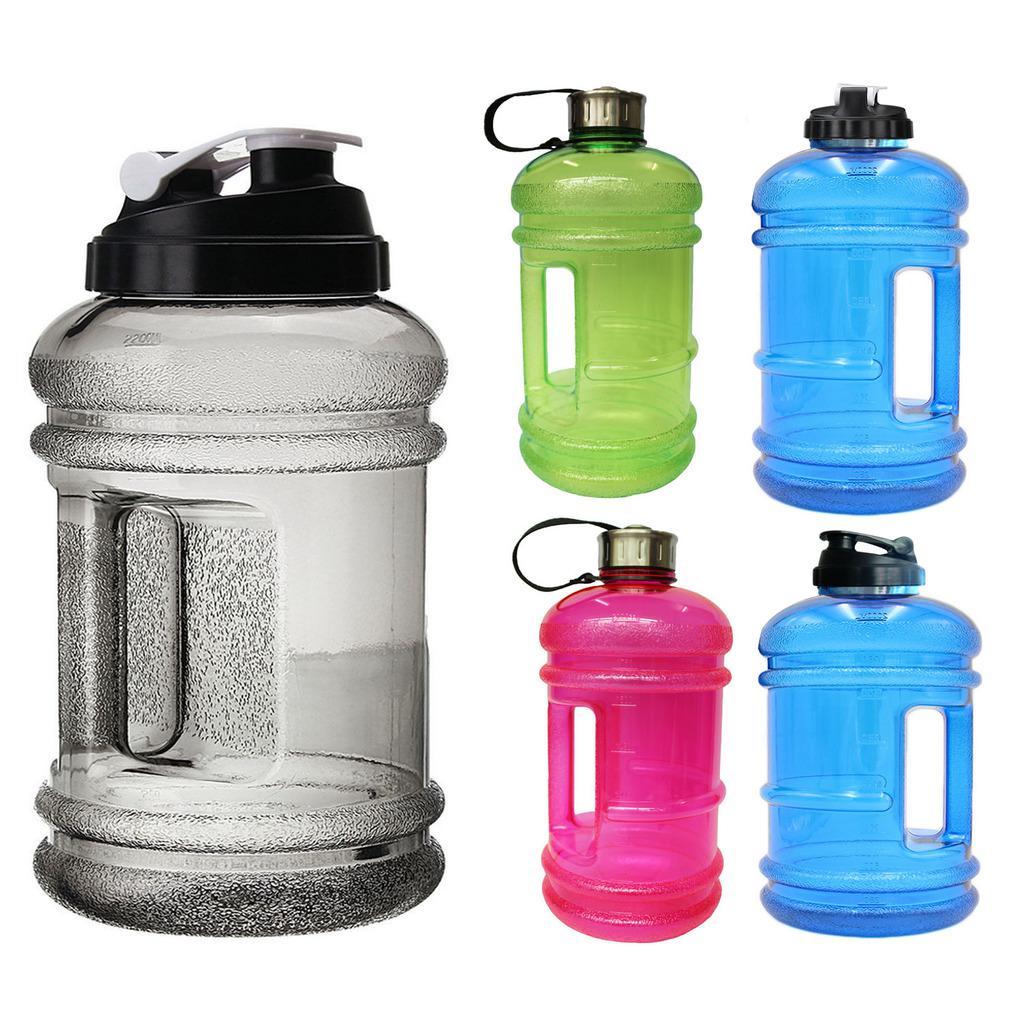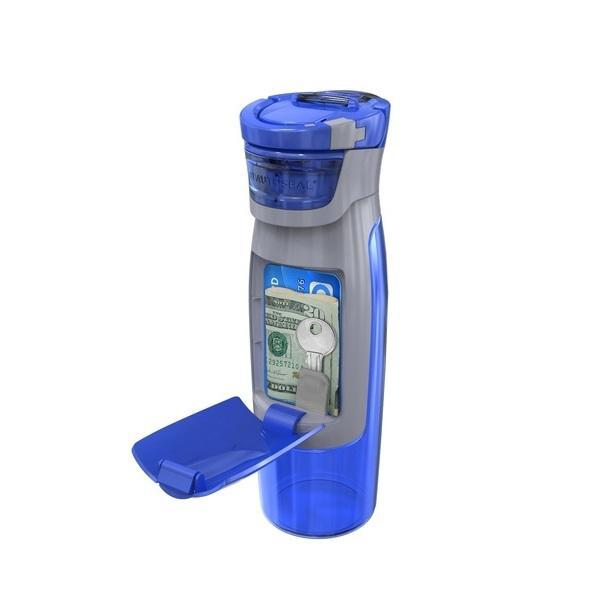The first image is the image on the left, the second image is the image on the right. Examine the images to the left and right. Is the description "There are three plastic drinking containers with lids." accurate? Answer yes or no. No. The first image is the image on the left, the second image is the image on the right. Analyze the images presented: Is the assertion "At least one water bottle is jug-shaped with a built-in side handle and a flip top, and one water bottle is hot pink." valid? Answer yes or no. Yes. 